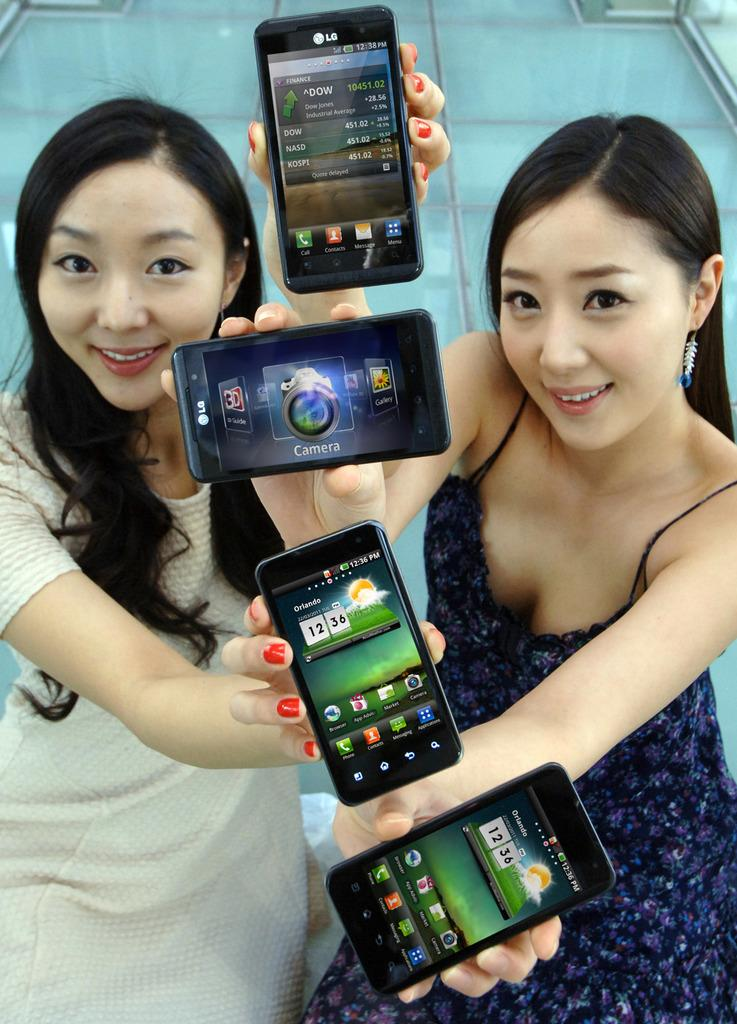<image>
Create a compact narrative representing the image presented. Two women are holding four phones, all showing the time of 12:36 PM. 